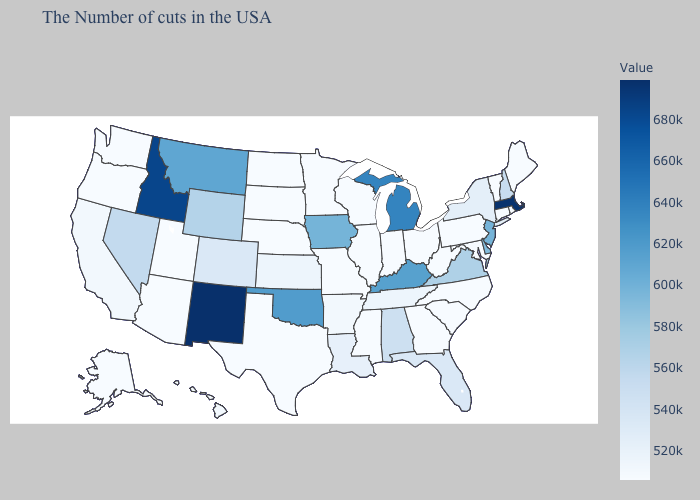Among the states that border New York , does Pennsylvania have the highest value?
Short answer required. No. Among the states that border Delaware , which have the highest value?
Short answer required. New Jersey. Among the states that border Iowa , which have the lowest value?
Be succinct. Wisconsin, Illinois, Missouri, Minnesota, Nebraska, South Dakota. Among the states that border Illinois , which have the lowest value?
Quick response, please. Indiana, Wisconsin, Missouri. Which states have the lowest value in the MidWest?
Give a very brief answer. Ohio, Indiana, Wisconsin, Illinois, Missouri, Minnesota, Nebraska, South Dakota, North Dakota. Does Wyoming have a higher value than Idaho?
Give a very brief answer. No. 